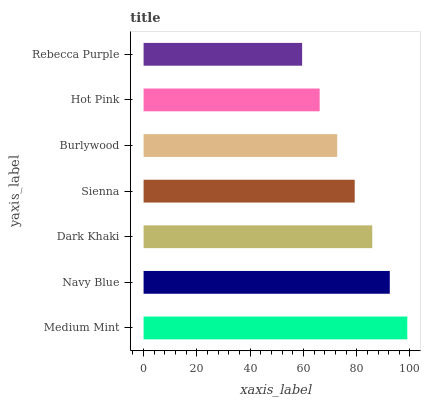Is Rebecca Purple the minimum?
Answer yes or no. Yes. Is Medium Mint the maximum?
Answer yes or no. Yes. Is Navy Blue the minimum?
Answer yes or no. No. Is Navy Blue the maximum?
Answer yes or no. No. Is Medium Mint greater than Navy Blue?
Answer yes or no. Yes. Is Navy Blue less than Medium Mint?
Answer yes or no. Yes. Is Navy Blue greater than Medium Mint?
Answer yes or no. No. Is Medium Mint less than Navy Blue?
Answer yes or no. No. Is Sienna the high median?
Answer yes or no. Yes. Is Sienna the low median?
Answer yes or no. Yes. Is Navy Blue the high median?
Answer yes or no. No. Is Burlywood the low median?
Answer yes or no. No. 